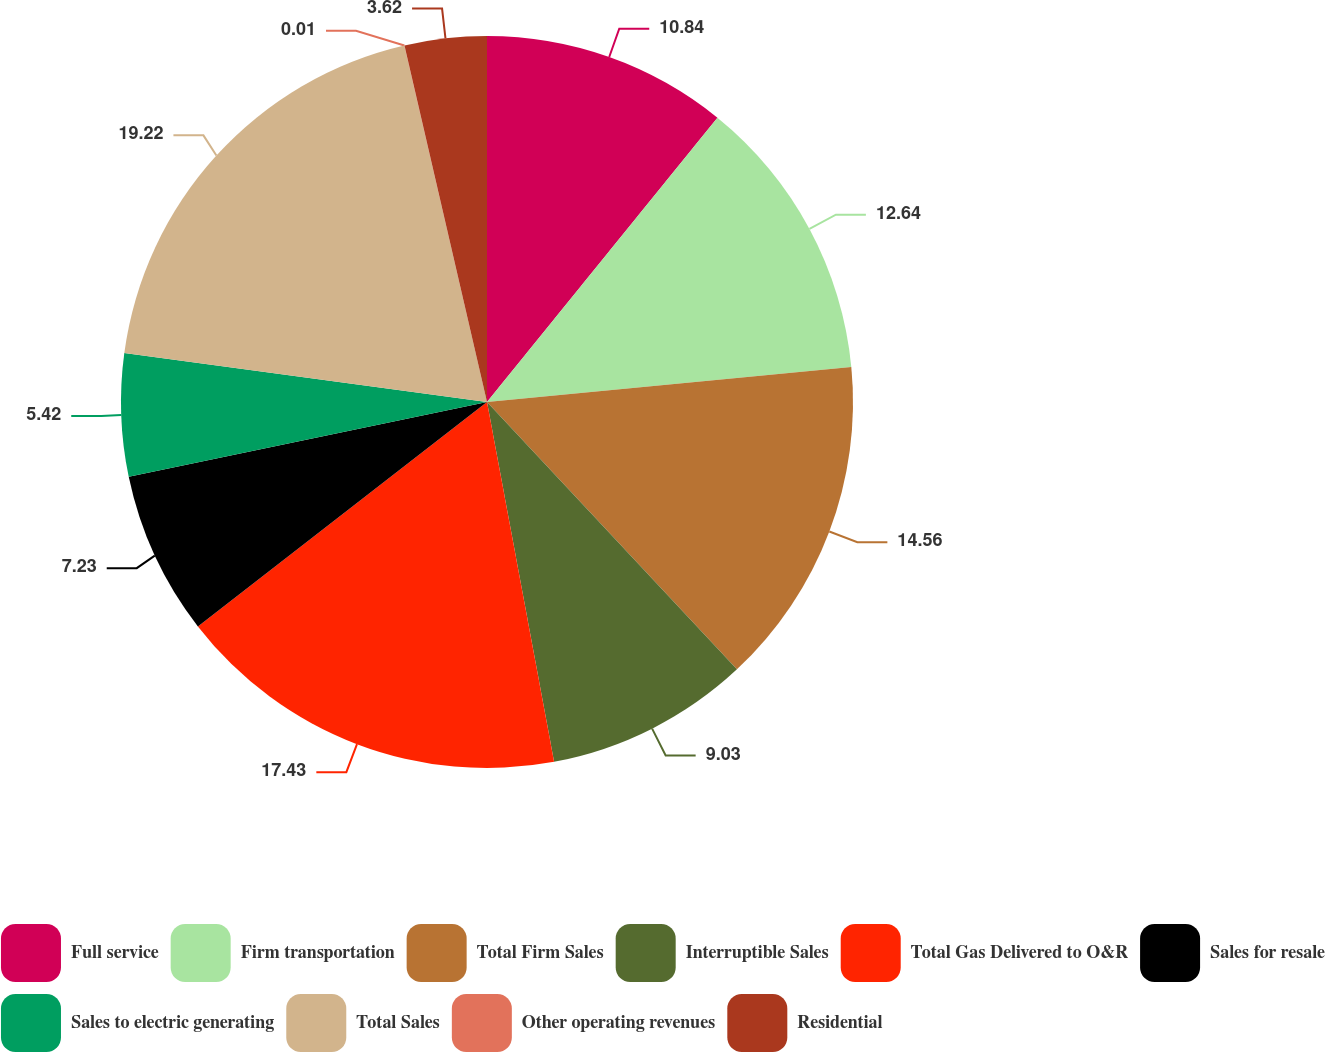Convert chart. <chart><loc_0><loc_0><loc_500><loc_500><pie_chart><fcel>Full service<fcel>Firm transportation<fcel>Total Firm Sales<fcel>Interruptible Sales<fcel>Total Gas Delivered to O&R<fcel>Sales for resale<fcel>Sales to electric generating<fcel>Total Sales<fcel>Other operating revenues<fcel>Residential<nl><fcel>10.84%<fcel>12.64%<fcel>14.56%<fcel>9.03%<fcel>17.43%<fcel>7.23%<fcel>5.42%<fcel>19.23%<fcel>0.01%<fcel>3.62%<nl></chart> 